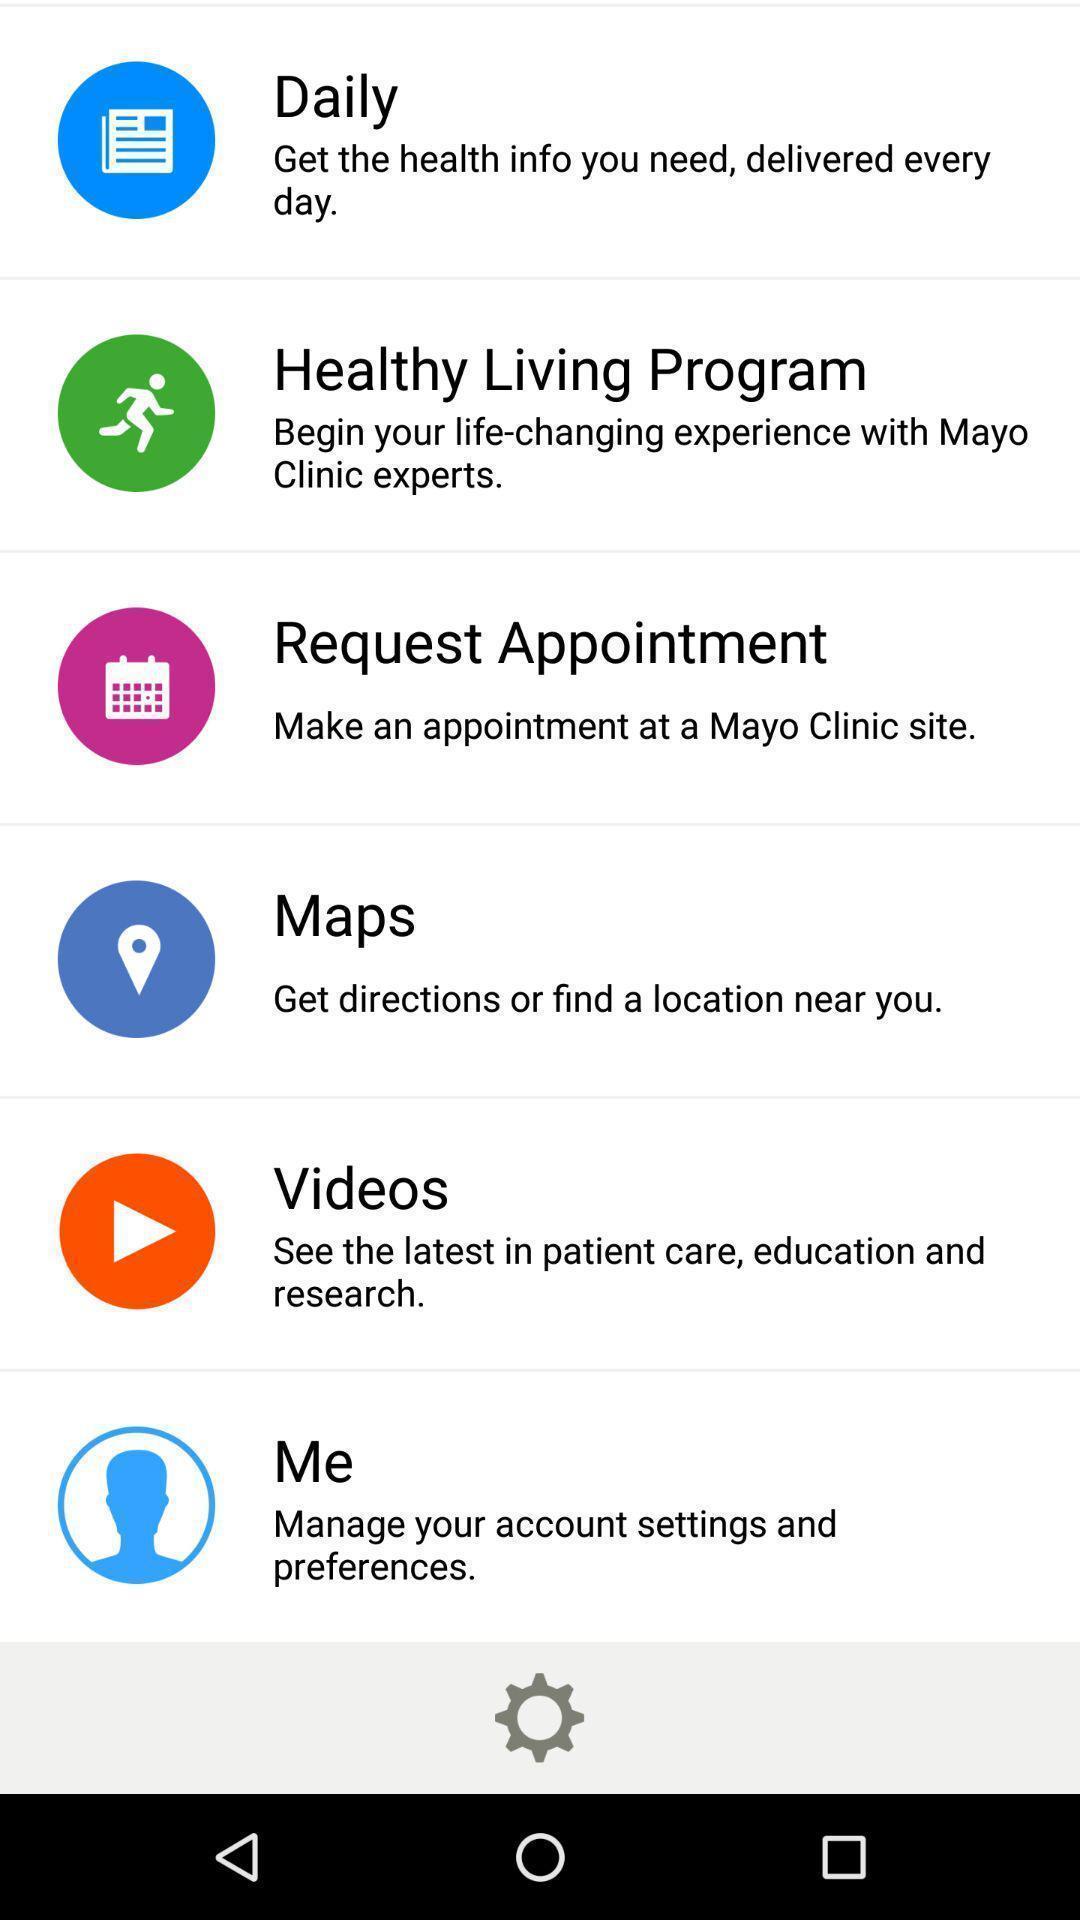Explain the elements present in this screenshot. Page showing various categories in health app. 